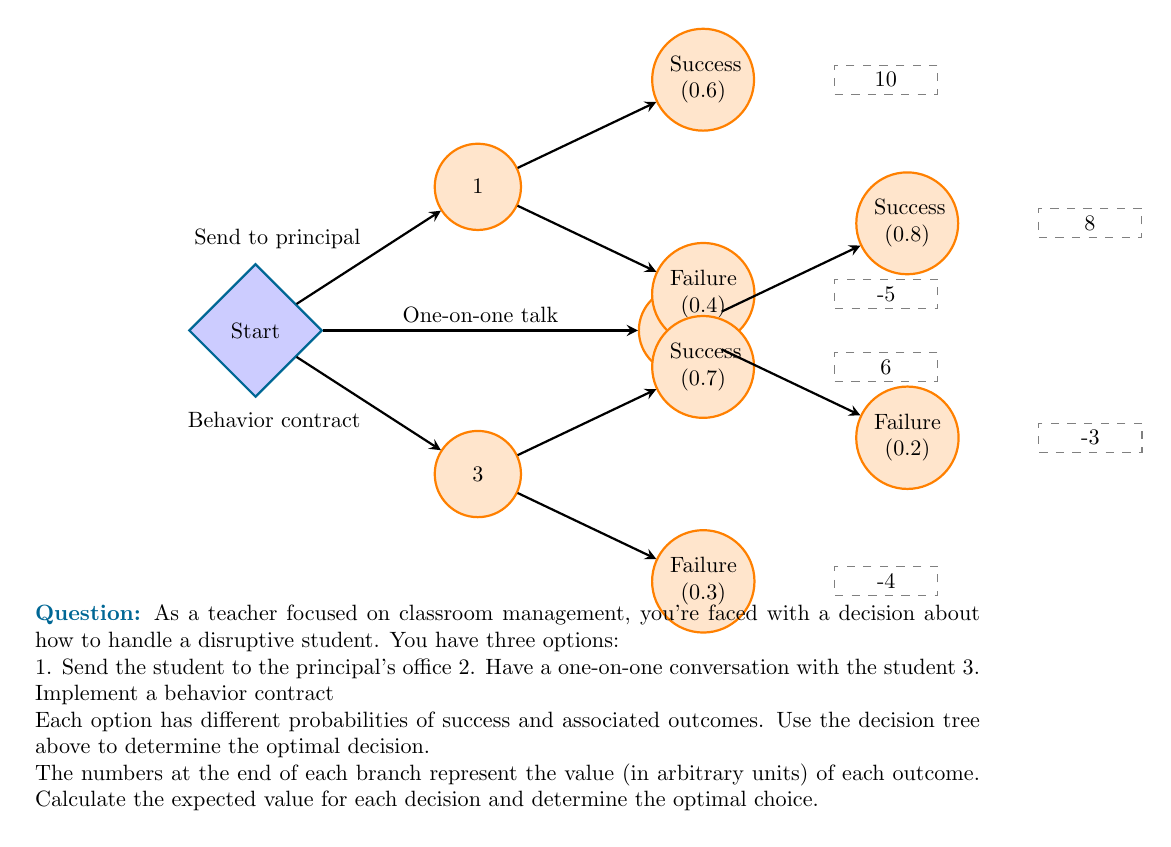Show me your answer to this math problem. To solve this problem, we'll calculate the expected value for each decision:

1. Send the student to the principal's office:
   $EV_1 = 0.6 \times 10 + 0.4 \times (-5) = 6 - 2 = 4$

2. Have a one-on-one conversation:
   $EV_2 = 0.8 \times 8 + 0.2 \times (-3) = 6.4 - 0.6 = 5.8$

3. Implement a behavior contract:
   $EV_3 = 0.7 \times 6 + 0.3 \times (-4) = 4.2 - 1.2 = 3$

The expected value (EV) for each decision is calculated by multiplying the probability of each outcome by its value and then summing these products for each decision.

To determine the optimal decision, we compare the expected values:

$EV_1 = 4$
$EV_2 = 5.8$
$EV_3 = 3$

The highest expected value is $EV_2 = 5.8$, which corresponds to having a one-on-one conversation with the student.
Answer: Option 2: Have a one-on-one conversation with the student (Expected Value = 5.8) 